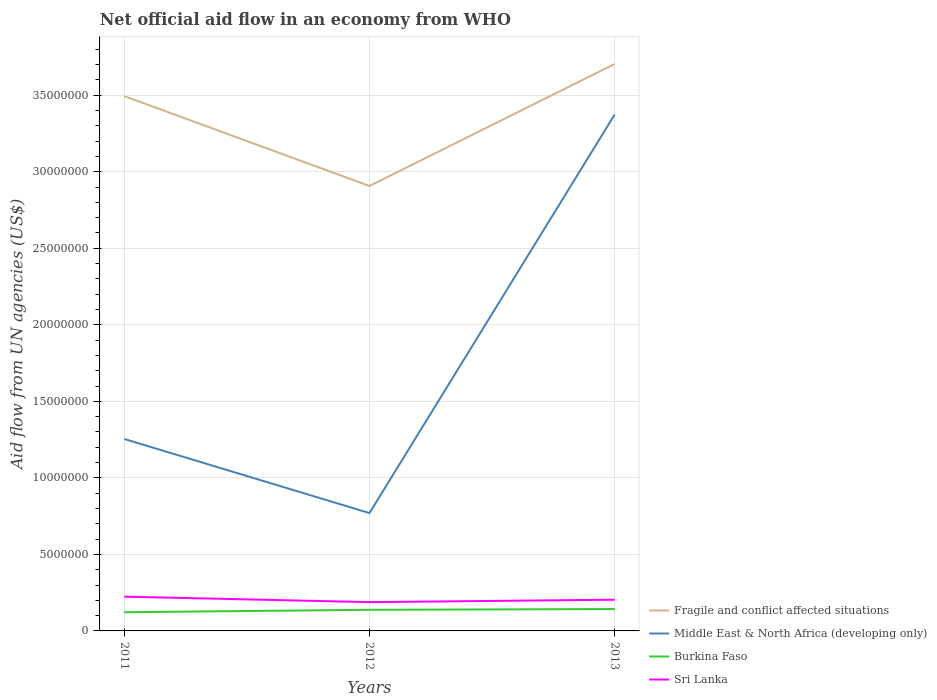Is the number of lines equal to the number of legend labels?
Keep it short and to the point. Yes. Across all years, what is the maximum net official aid flow in Burkina Faso?
Offer a very short reply. 1.22e+06. In which year was the net official aid flow in Burkina Faso maximum?
Give a very brief answer. 2011. What is the total net official aid flow in Fragile and conflict affected situations in the graph?
Your answer should be compact. -2.10e+06. What is the difference between the highest and the second highest net official aid flow in Middle East & North Africa (developing only)?
Keep it short and to the point. 2.60e+07. Is the net official aid flow in Burkina Faso strictly greater than the net official aid flow in Sri Lanka over the years?
Give a very brief answer. Yes. How many years are there in the graph?
Your answer should be very brief. 3. What is the difference between two consecutive major ticks on the Y-axis?
Your answer should be compact. 5.00e+06. Does the graph contain any zero values?
Your answer should be compact. No. Where does the legend appear in the graph?
Ensure brevity in your answer.  Bottom right. How many legend labels are there?
Your answer should be very brief. 4. How are the legend labels stacked?
Keep it short and to the point. Vertical. What is the title of the graph?
Give a very brief answer. Net official aid flow in an economy from WHO. What is the label or title of the Y-axis?
Provide a short and direct response. Aid flow from UN agencies (US$). What is the Aid flow from UN agencies (US$) in Fragile and conflict affected situations in 2011?
Provide a succinct answer. 3.49e+07. What is the Aid flow from UN agencies (US$) of Middle East & North Africa (developing only) in 2011?
Provide a succinct answer. 1.25e+07. What is the Aid flow from UN agencies (US$) of Burkina Faso in 2011?
Offer a terse response. 1.22e+06. What is the Aid flow from UN agencies (US$) of Sri Lanka in 2011?
Give a very brief answer. 2.24e+06. What is the Aid flow from UN agencies (US$) of Fragile and conflict affected situations in 2012?
Ensure brevity in your answer.  2.91e+07. What is the Aid flow from UN agencies (US$) in Middle East & North Africa (developing only) in 2012?
Offer a terse response. 7.70e+06. What is the Aid flow from UN agencies (US$) in Burkina Faso in 2012?
Provide a short and direct response. 1.38e+06. What is the Aid flow from UN agencies (US$) of Sri Lanka in 2012?
Make the answer very short. 1.88e+06. What is the Aid flow from UN agencies (US$) of Fragile and conflict affected situations in 2013?
Your response must be concise. 3.70e+07. What is the Aid flow from UN agencies (US$) in Middle East & North Africa (developing only) in 2013?
Your response must be concise. 3.37e+07. What is the Aid flow from UN agencies (US$) in Burkina Faso in 2013?
Ensure brevity in your answer.  1.43e+06. What is the Aid flow from UN agencies (US$) in Sri Lanka in 2013?
Ensure brevity in your answer.  2.04e+06. Across all years, what is the maximum Aid flow from UN agencies (US$) in Fragile and conflict affected situations?
Your answer should be compact. 3.70e+07. Across all years, what is the maximum Aid flow from UN agencies (US$) of Middle East & North Africa (developing only)?
Make the answer very short. 3.37e+07. Across all years, what is the maximum Aid flow from UN agencies (US$) in Burkina Faso?
Offer a terse response. 1.43e+06. Across all years, what is the maximum Aid flow from UN agencies (US$) of Sri Lanka?
Provide a short and direct response. 2.24e+06. Across all years, what is the minimum Aid flow from UN agencies (US$) in Fragile and conflict affected situations?
Give a very brief answer. 2.91e+07. Across all years, what is the minimum Aid flow from UN agencies (US$) of Middle East & North Africa (developing only)?
Offer a terse response. 7.70e+06. Across all years, what is the minimum Aid flow from UN agencies (US$) of Burkina Faso?
Offer a terse response. 1.22e+06. Across all years, what is the minimum Aid flow from UN agencies (US$) in Sri Lanka?
Provide a short and direct response. 1.88e+06. What is the total Aid flow from UN agencies (US$) of Fragile and conflict affected situations in the graph?
Ensure brevity in your answer.  1.01e+08. What is the total Aid flow from UN agencies (US$) in Middle East & North Africa (developing only) in the graph?
Offer a terse response. 5.40e+07. What is the total Aid flow from UN agencies (US$) of Burkina Faso in the graph?
Offer a very short reply. 4.03e+06. What is the total Aid flow from UN agencies (US$) of Sri Lanka in the graph?
Ensure brevity in your answer.  6.16e+06. What is the difference between the Aid flow from UN agencies (US$) in Fragile and conflict affected situations in 2011 and that in 2012?
Your answer should be compact. 5.87e+06. What is the difference between the Aid flow from UN agencies (US$) of Middle East & North Africa (developing only) in 2011 and that in 2012?
Your response must be concise. 4.84e+06. What is the difference between the Aid flow from UN agencies (US$) of Sri Lanka in 2011 and that in 2012?
Ensure brevity in your answer.  3.60e+05. What is the difference between the Aid flow from UN agencies (US$) in Fragile and conflict affected situations in 2011 and that in 2013?
Offer a very short reply. -2.10e+06. What is the difference between the Aid flow from UN agencies (US$) in Middle East & North Africa (developing only) in 2011 and that in 2013?
Your answer should be very brief. -2.12e+07. What is the difference between the Aid flow from UN agencies (US$) of Sri Lanka in 2011 and that in 2013?
Provide a short and direct response. 2.00e+05. What is the difference between the Aid flow from UN agencies (US$) in Fragile and conflict affected situations in 2012 and that in 2013?
Offer a terse response. -7.97e+06. What is the difference between the Aid flow from UN agencies (US$) of Middle East & North Africa (developing only) in 2012 and that in 2013?
Provide a short and direct response. -2.60e+07. What is the difference between the Aid flow from UN agencies (US$) in Burkina Faso in 2012 and that in 2013?
Provide a succinct answer. -5.00e+04. What is the difference between the Aid flow from UN agencies (US$) of Sri Lanka in 2012 and that in 2013?
Offer a very short reply. -1.60e+05. What is the difference between the Aid flow from UN agencies (US$) in Fragile and conflict affected situations in 2011 and the Aid flow from UN agencies (US$) in Middle East & North Africa (developing only) in 2012?
Offer a terse response. 2.72e+07. What is the difference between the Aid flow from UN agencies (US$) of Fragile and conflict affected situations in 2011 and the Aid flow from UN agencies (US$) of Burkina Faso in 2012?
Your answer should be very brief. 3.36e+07. What is the difference between the Aid flow from UN agencies (US$) of Fragile and conflict affected situations in 2011 and the Aid flow from UN agencies (US$) of Sri Lanka in 2012?
Offer a very short reply. 3.31e+07. What is the difference between the Aid flow from UN agencies (US$) of Middle East & North Africa (developing only) in 2011 and the Aid flow from UN agencies (US$) of Burkina Faso in 2012?
Your answer should be compact. 1.12e+07. What is the difference between the Aid flow from UN agencies (US$) of Middle East & North Africa (developing only) in 2011 and the Aid flow from UN agencies (US$) of Sri Lanka in 2012?
Your answer should be compact. 1.07e+07. What is the difference between the Aid flow from UN agencies (US$) of Burkina Faso in 2011 and the Aid flow from UN agencies (US$) of Sri Lanka in 2012?
Your response must be concise. -6.60e+05. What is the difference between the Aid flow from UN agencies (US$) of Fragile and conflict affected situations in 2011 and the Aid flow from UN agencies (US$) of Middle East & North Africa (developing only) in 2013?
Your answer should be very brief. 1.21e+06. What is the difference between the Aid flow from UN agencies (US$) of Fragile and conflict affected situations in 2011 and the Aid flow from UN agencies (US$) of Burkina Faso in 2013?
Offer a terse response. 3.35e+07. What is the difference between the Aid flow from UN agencies (US$) in Fragile and conflict affected situations in 2011 and the Aid flow from UN agencies (US$) in Sri Lanka in 2013?
Make the answer very short. 3.29e+07. What is the difference between the Aid flow from UN agencies (US$) of Middle East & North Africa (developing only) in 2011 and the Aid flow from UN agencies (US$) of Burkina Faso in 2013?
Your answer should be compact. 1.11e+07. What is the difference between the Aid flow from UN agencies (US$) in Middle East & North Africa (developing only) in 2011 and the Aid flow from UN agencies (US$) in Sri Lanka in 2013?
Offer a terse response. 1.05e+07. What is the difference between the Aid flow from UN agencies (US$) in Burkina Faso in 2011 and the Aid flow from UN agencies (US$) in Sri Lanka in 2013?
Make the answer very short. -8.20e+05. What is the difference between the Aid flow from UN agencies (US$) in Fragile and conflict affected situations in 2012 and the Aid flow from UN agencies (US$) in Middle East & North Africa (developing only) in 2013?
Your answer should be compact. -4.66e+06. What is the difference between the Aid flow from UN agencies (US$) in Fragile and conflict affected situations in 2012 and the Aid flow from UN agencies (US$) in Burkina Faso in 2013?
Ensure brevity in your answer.  2.76e+07. What is the difference between the Aid flow from UN agencies (US$) in Fragile and conflict affected situations in 2012 and the Aid flow from UN agencies (US$) in Sri Lanka in 2013?
Offer a terse response. 2.70e+07. What is the difference between the Aid flow from UN agencies (US$) in Middle East & North Africa (developing only) in 2012 and the Aid flow from UN agencies (US$) in Burkina Faso in 2013?
Your answer should be compact. 6.27e+06. What is the difference between the Aid flow from UN agencies (US$) of Middle East & North Africa (developing only) in 2012 and the Aid flow from UN agencies (US$) of Sri Lanka in 2013?
Your answer should be very brief. 5.66e+06. What is the difference between the Aid flow from UN agencies (US$) of Burkina Faso in 2012 and the Aid flow from UN agencies (US$) of Sri Lanka in 2013?
Offer a very short reply. -6.60e+05. What is the average Aid flow from UN agencies (US$) of Fragile and conflict affected situations per year?
Ensure brevity in your answer.  3.37e+07. What is the average Aid flow from UN agencies (US$) in Middle East & North Africa (developing only) per year?
Ensure brevity in your answer.  1.80e+07. What is the average Aid flow from UN agencies (US$) of Burkina Faso per year?
Provide a succinct answer. 1.34e+06. What is the average Aid flow from UN agencies (US$) in Sri Lanka per year?
Offer a very short reply. 2.05e+06. In the year 2011, what is the difference between the Aid flow from UN agencies (US$) of Fragile and conflict affected situations and Aid flow from UN agencies (US$) of Middle East & North Africa (developing only)?
Offer a terse response. 2.24e+07. In the year 2011, what is the difference between the Aid flow from UN agencies (US$) of Fragile and conflict affected situations and Aid flow from UN agencies (US$) of Burkina Faso?
Keep it short and to the point. 3.37e+07. In the year 2011, what is the difference between the Aid flow from UN agencies (US$) in Fragile and conflict affected situations and Aid flow from UN agencies (US$) in Sri Lanka?
Make the answer very short. 3.27e+07. In the year 2011, what is the difference between the Aid flow from UN agencies (US$) of Middle East & North Africa (developing only) and Aid flow from UN agencies (US$) of Burkina Faso?
Provide a short and direct response. 1.13e+07. In the year 2011, what is the difference between the Aid flow from UN agencies (US$) of Middle East & North Africa (developing only) and Aid flow from UN agencies (US$) of Sri Lanka?
Ensure brevity in your answer.  1.03e+07. In the year 2011, what is the difference between the Aid flow from UN agencies (US$) in Burkina Faso and Aid flow from UN agencies (US$) in Sri Lanka?
Give a very brief answer. -1.02e+06. In the year 2012, what is the difference between the Aid flow from UN agencies (US$) in Fragile and conflict affected situations and Aid flow from UN agencies (US$) in Middle East & North Africa (developing only)?
Your response must be concise. 2.14e+07. In the year 2012, what is the difference between the Aid flow from UN agencies (US$) of Fragile and conflict affected situations and Aid flow from UN agencies (US$) of Burkina Faso?
Keep it short and to the point. 2.77e+07. In the year 2012, what is the difference between the Aid flow from UN agencies (US$) of Fragile and conflict affected situations and Aid flow from UN agencies (US$) of Sri Lanka?
Provide a short and direct response. 2.72e+07. In the year 2012, what is the difference between the Aid flow from UN agencies (US$) of Middle East & North Africa (developing only) and Aid flow from UN agencies (US$) of Burkina Faso?
Provide a short and direct response. 6.32e+06. In the year 2012, what is the difference between the Aid flow from UN agencies (US$) of Middle East & North Africa (developing only) and Aid flow from UN agencies (US$) of Sri Lanka?
Keep it short and to the point. 5.82e+06. In the year 2012, what is the difference between the Aid flow from UN agencies (US$) in Burkina Faso and Aid flow from UN agencies (US$) in Sri Lanka?
Ensure brevity in your answer.  -5.00e+05. In the year 2013, what is the difference between the Aid flow from UN agencies (US$) of Fragile and conflict affected situations and Aid flow from UN agencies (US$) of Middle East & North Africa (developing only)?
Make the answer very short. 3.31e+06. In the year 2013, what is the difference between the Aid flow from UN agencies (US$) in Fragile and conflict affected situations and Aid flow from UN agencies (US$) in Burkina Faso?
Your response must be concise. 3.56e+07. In the year 2013, what is the difference between the Aid flow from UN agencies (US$) of Fragile and conflict affected situations and Aid flow from UN agencies (US$) of Sri Lanka?
Your answer should be very brief. 3.50e+07. In the year 2013, what is the difference between the Aid flow from UN agencies (US$) of Middle East & North Africa (developing only) and Aid flow from UN agencies (US$) of Burkina Faso?
Your answer should be very brief. 3.23e+07. In the year 2013, what is the difference between the Aid flow from UN agencies (US$) in Middle East & North Africa (developing only) and Aid flow from UN agencies (US$) in Sri Lanka?
Ensure brevity in your answer.  3.17e+07. In the year 2013, what is the difference between the Aid flow from UN agencies (US$) in Burkina Faso and Aid flow from UN agencies (US$) in Sri Lanka?
Ensure brevity in your answer.  -6.10e+05. What is the ratio of the Aid flow from UN agencies (US$) of Fragile and conflict affected situations in 2011 to that in 2012?
Keep it short and to the point. 1.2. What is the ratio of the Aid flow from UN agencies (US$) in Middle East & North Africa (developing only) in 2011 to that in 2012?
Ensure brevity in your answer.  1.63. What is the ratio of the Aid flow from UN agencies (US$) in Burkina Faso in 2011 to that in 2012?
Offer a terse response. 0.88. What is the ratio of the Aid flow from UN agencies (US$) of Sri Lanka in 2011 to that in 2012?
Provide a short and direct response. 1.19. What is the ratio of the Aid flow from UN agencies (US$) of Fragile and conflict affected situations in 2011 to that in 2013?
Provide a succinct answer. 0.94. What is the ratio of the Aid flow from UN agencies (US$) of Middle East & North Africa (developing only) in 2011 to that in 2013?
Make the answer very short. 0.37. What is the ratio of the Aid flow from UN agencies (US$) of Burkina Faso in 2011 to that in 2013?
Your response must be concise. 0.85. What is the ratio of the Aid flow from UN agencies (US$) of Sri Lanka in 2011 to that in 2013?
Ensure brevity in your answer.  1.1. What is the ratio of the Aid flow from UN agencies (US$) of Fragile and conflict affected situations in 2012 to that in 2013?
Your answer should be very brief. 0.78. What is the ratio of the Aid flow from UN agencies (US$) of Middle East & North Africa (developing only) in 2012 to that in 2013?
Give a very brief answer. 0.23. What is the ratio of the Aid flow from UN agencies (US$) of Sri Lanka in 2012 to that in 2013?
Your answer should be very brief. 0.92. What is the difference between the highest and the second highest Aid flow from UN agencies (US$) of Fragile and conflict affected situations?
Provide a succinct answer. 2.10e+06. What is the difference between the highest and the second highest Aid flow from UN agencies (US$) of Middle East & North Africa (developing only)?
Give a very brief answer. 2.12e+07. What is the difference between the highest and the lowest Aid flow from UN agencies (US$) in Fragile and conflict affected situations?
Give a very brief answer. 7.97e+06. What is the difference between the highest and the lowest Aid flow from UN agencies (US$) of Middle East & North Africa (developing only)?
Your answer should be compact. 2.60e+07. What is the difference between the highest and the lowest Aid flow from UN agencies (US$) in Burkina Faso?
Keep it short and to the point. 2.10e+05. What is the difference between the highest and the lowest Aid flow from UN agencies (US$) of Sri Lanka?
Your response must be concise. 3.60e+05. 